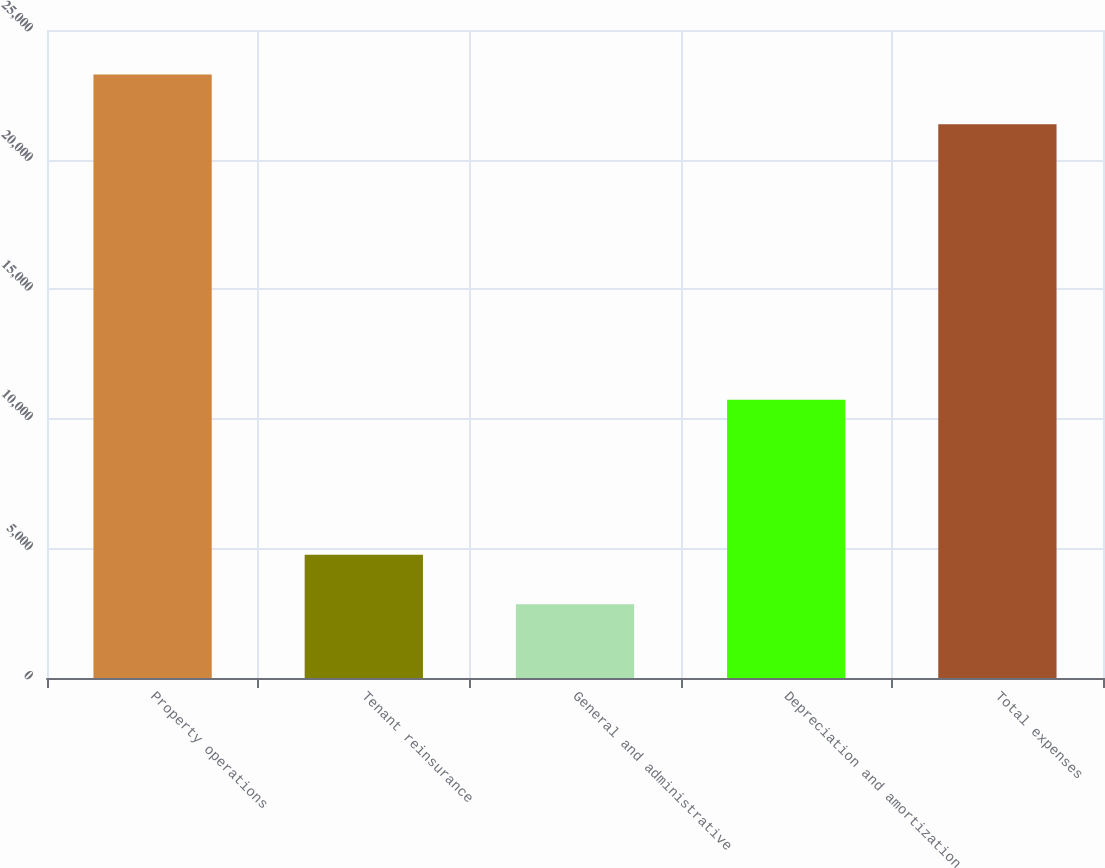<chart> <loc_0><loc_0><loc_500><loc_500><bar_chart><fcel>Property operations<fcel>Tenant reinsurance<fcel>General and administrative<fcel>Depreciation and amortization<fcel>Total expenses<nl><fcel>23279.4<fcel>4757.4<fcel>2845<fcel>10736<fcel>21367<nl></chart> 